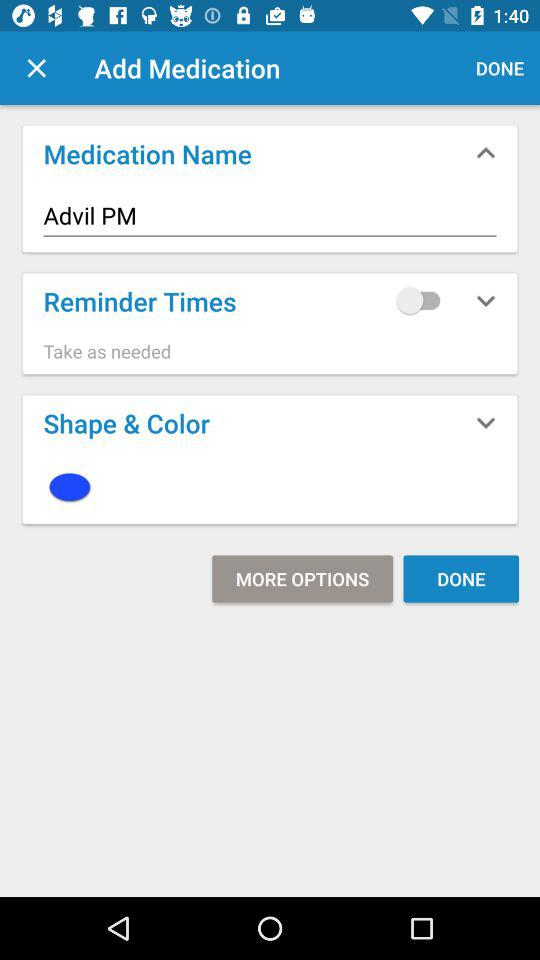Who is this application powered by?
When the provided information is insufficient, respond with <no answer>. <no answer> 